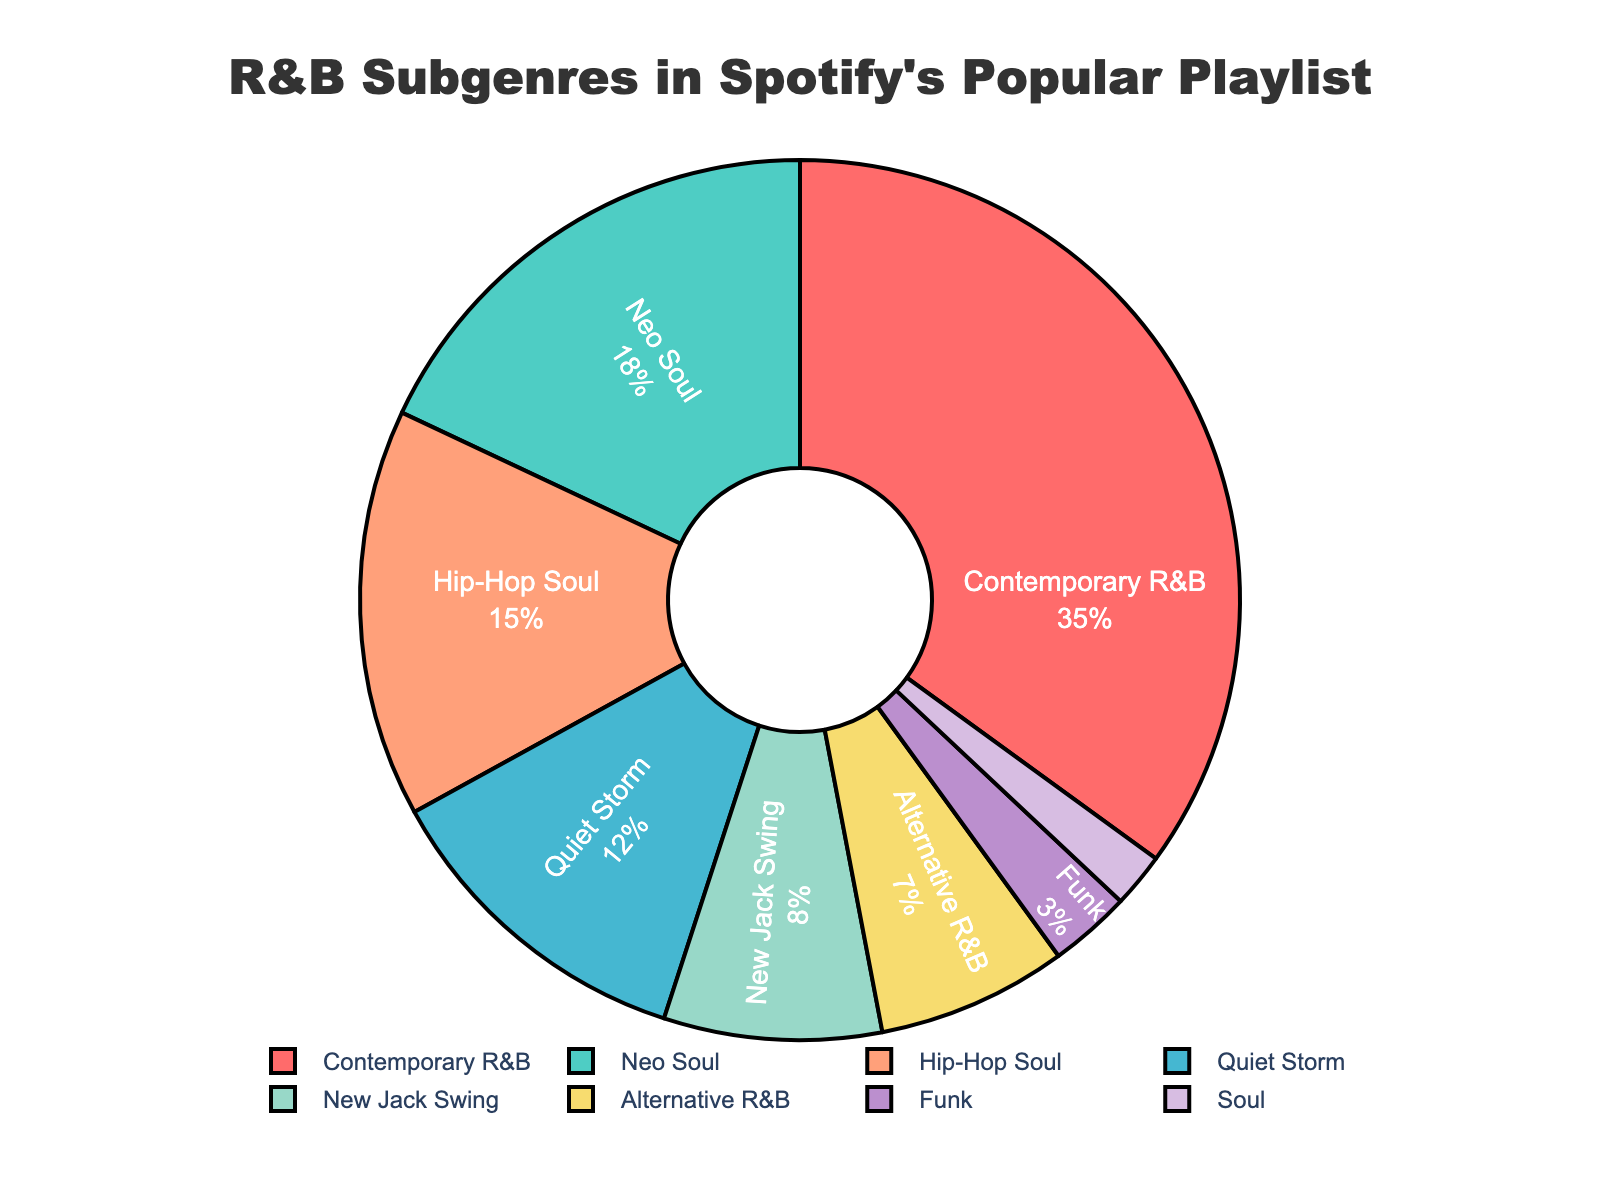What's the most popular subgenre in Spotify's R&B playlist? Referring to the figure, the subgenre with the largest section in the pie chart is Contemporary R&B.
Answer: Contemporary R&B What's the least popular subgenre in the playlist? The smallest section in the pie chart corresponds to Soul.
Answer: Soul Which subgenre has a larger percentage, Neo Soul or Hip-Hop Soul? By comparing the sizes of the respective sections, Neo Soul has a larger percentage (18%) compared to Hip-Hop Soul (15%).
Answer: Neo Soul What is the combined percentage of Neo Soul, Quiet Storm, and New Jack Swing? Adding up the percentages of Neo Soul (18%), Quiet Storm (12%), and New Jack Swing (8%) gives 18 + 12 + 8 = 38%.
Answer: 38% How much more popular is Contemporary R&B compared to Alternative R&B? Subtract the percentage of Alternative R&B (7%) from Contemporary R&B (35%): 35 - 7 = 28%.
Answer: 28% How many subgenres have a percentage less than 10? The subgenres with percentages less than 10 are New Jack Swing (8%), Alternative R&B (7%), Funk (3%), and Soul (2%). This gives a total of 4 subgenres.
Answer: 4 What proportion of the playlist is made up of Alternative R&B and Funk? Adding the percentages of Alternative R&B (7%) and Funk (3%) gives 7 + 3 = 10%.
Answer: 10% Which subgenre is represented by a blue color in the pie chart? The blue color in the pie chart corresponds to Neo Soul.
Answer: Neo Soul Is the percentage of Hip-Hop Soul greater than the combined percentage of Soul and Funk? The combined percentage of Soul (2%) and Funk (3%) is 2 + 3 = 5%. Hip-Hop Soul has a percentage of 15%, which is greater than 5%.
Answer: Yes What's the average percentage of Contemporary R&B, Neo Soul, and Quiet Storm? Sum the percentages: Contemporary R&B (35%) + Neo Soul (18%) + Quiet Storm (12%) = 65%. Then, divide by the number of subgenres (3): 65 / 3 ≈ 21.67%.
Answer: ~21.67% 